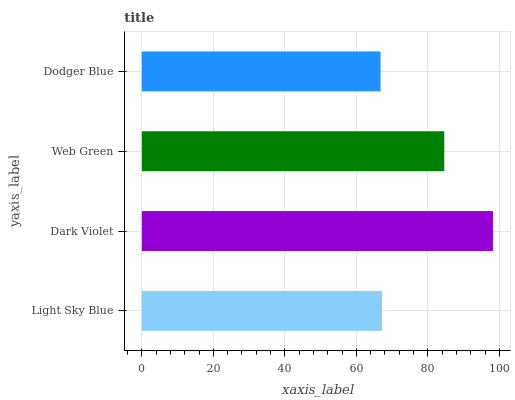Is Dodger Blue the minimum?
Answer yes or no. Yes. Is Dark Violet the maximum?
Answer yes or no. Yes. Is Web Green the minimum?
Answer yes or no. No. Is Web Green the maximum?
Answer yes or no. No. Is Dark Violet greater than Web Green?
Answer yes or no. Yes. Is Web Green less than Dark Violet?
Answer yes or no. Yes. Is Web Green greater than Dark Violet?
Answer yes or no. No. Is Dark Violet less than Web Green?
Answer yes or no. No. Is Web Green the high median?
Answer yes or no. Yes. Is Light Sky Blue the low median?
Answer yes or no. Yes. Is Dark Violet the high median?
Answer yes or no. No. Is Dark Violet the low median?
Answer yes or no. No. 